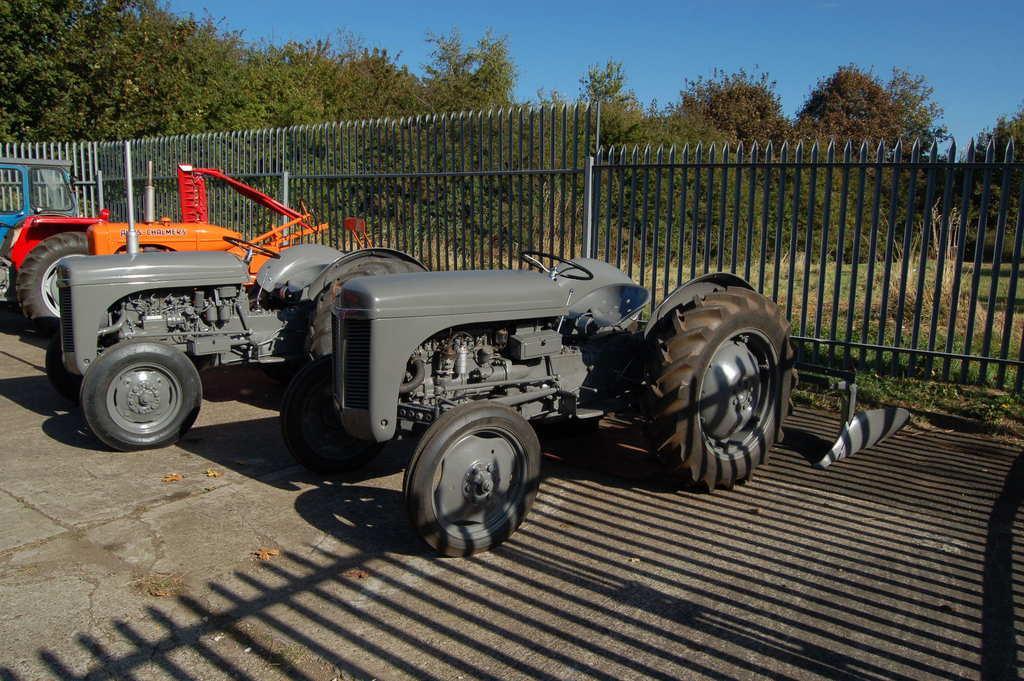Please provide a concise description of this image. In this image in the foreground there are tractors. Here there is boundary. in the background there are trees. This is the sky. 